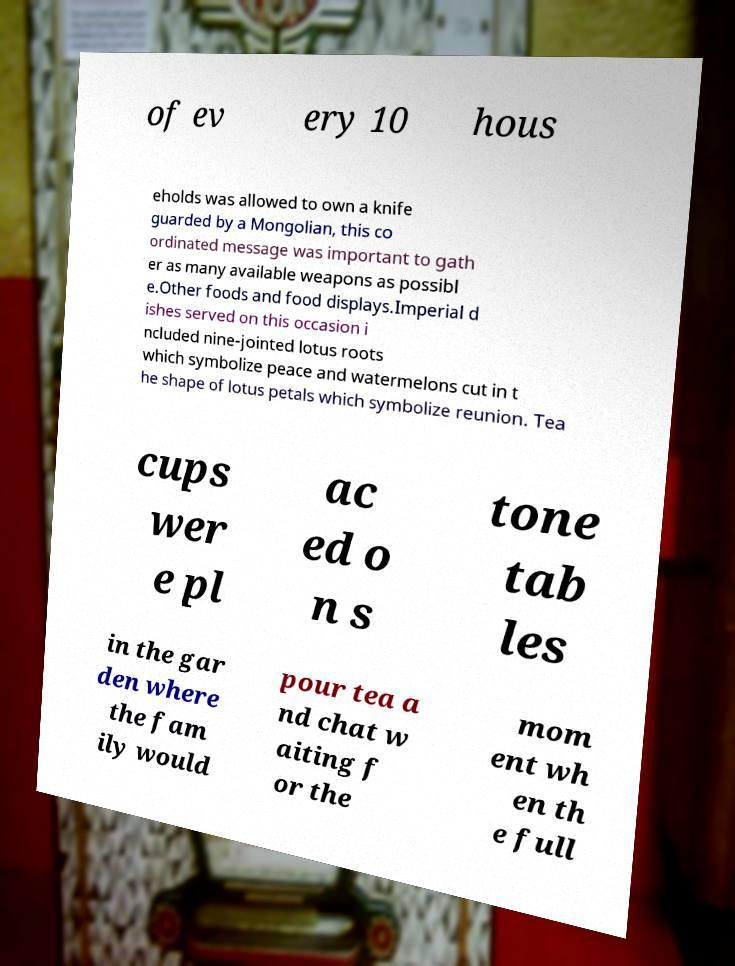Can you accurately transcribe the text from the provided image for me? of ev ery 10 hous eholds was allowed to own a knife guarded by a Mongolian, this co ordinated message was important to gath er as many available weapons as possibl e.Other foods and food displays.Imperial d ishes served on this occasion i ncluded nine-jointed lotus roots which symbolize peace and watermelons cut in t he shape of lotus petals which symbolize reunion. Tea cups wer e pl ac ed o n s tone tab les in the gar den where the fam ily would pour tea a nd chat w aiting f or the mom ent wh en th e full 